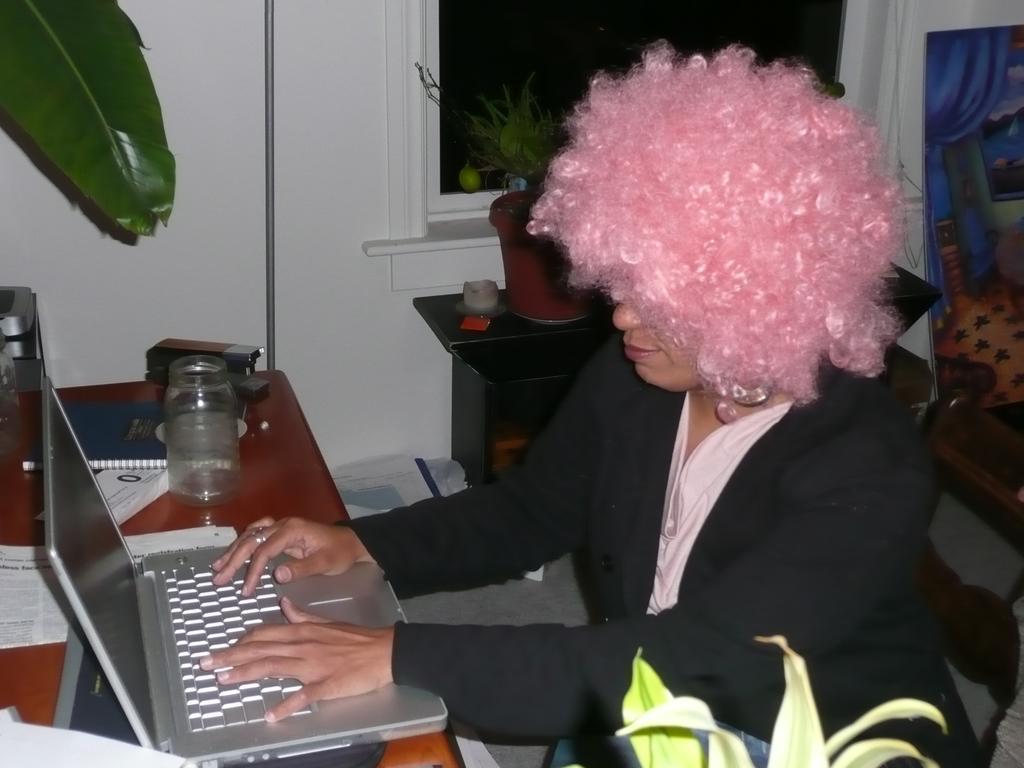In one or two sentences, can you explain what this image depicts? In this picture we can see a girl is sitting on a chair, and in front of her here is the table and she is working on the laptop, here is the jar and book ,and other objects on it. and here is the wall and right to opposite here is the table, and flower pot on it. 